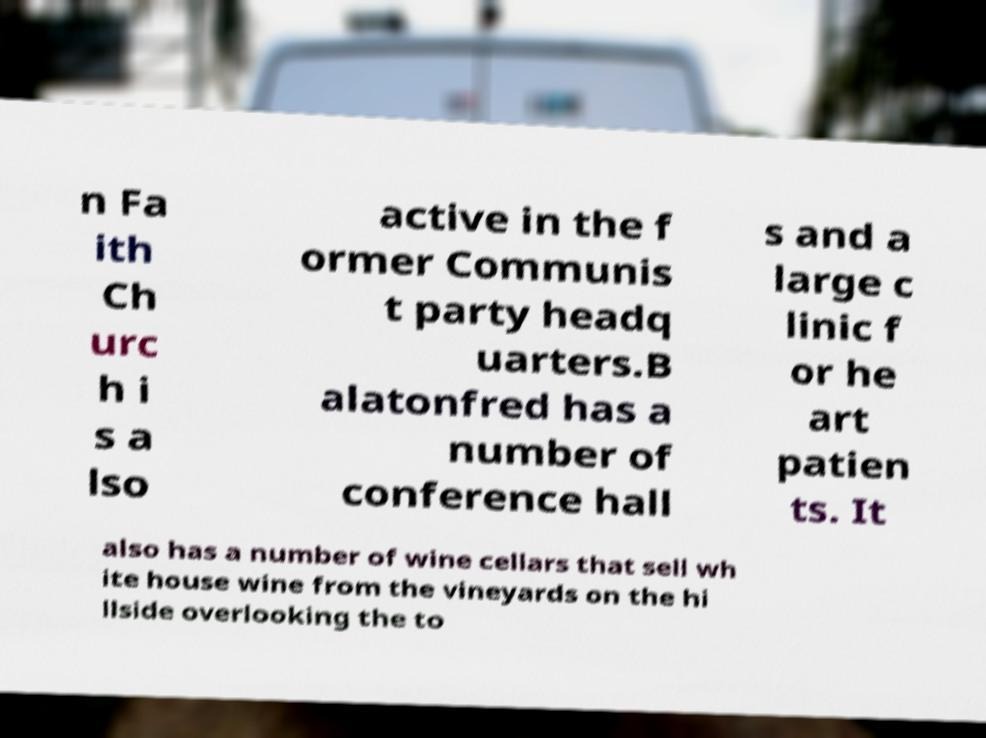Please read and relay the text visible in this image. What does it say? n Fa ith Ch urc h i s a lso active in the f ormer Communis t party headq uarters.B alatonfred has a number of conference hall s and a large c linic f or he art patien ts. It also has a number of wine cellars that sell wh ite house wine from the vineyards on the hi llside overlooking the to 